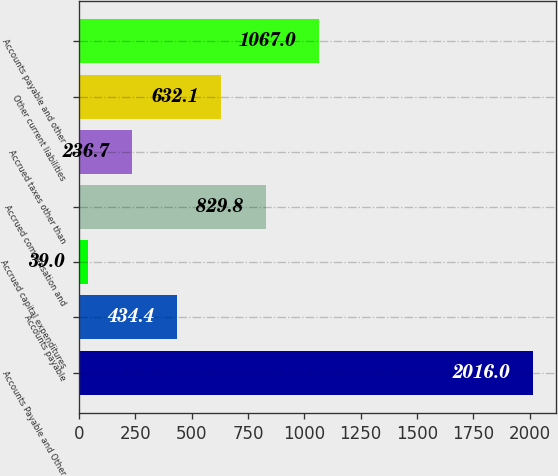<chart> <loc_0><loc_0><loc_500><loc_500><bar_chart><fcel>Accounts Payable and Other<fcel>Accounts payable<fcel>Accrued capital expenditures<fcel>Accrued compensation and<fcel>Accrued taxes other than<fcel>Other current liabilities<fcel>Accounts payable and other<nl><fcel>2016<fcel>434.4<fcel>39<fcel>829.8<fcel>236.7<fcel>632.1<fcel>1067<nl></chart> 